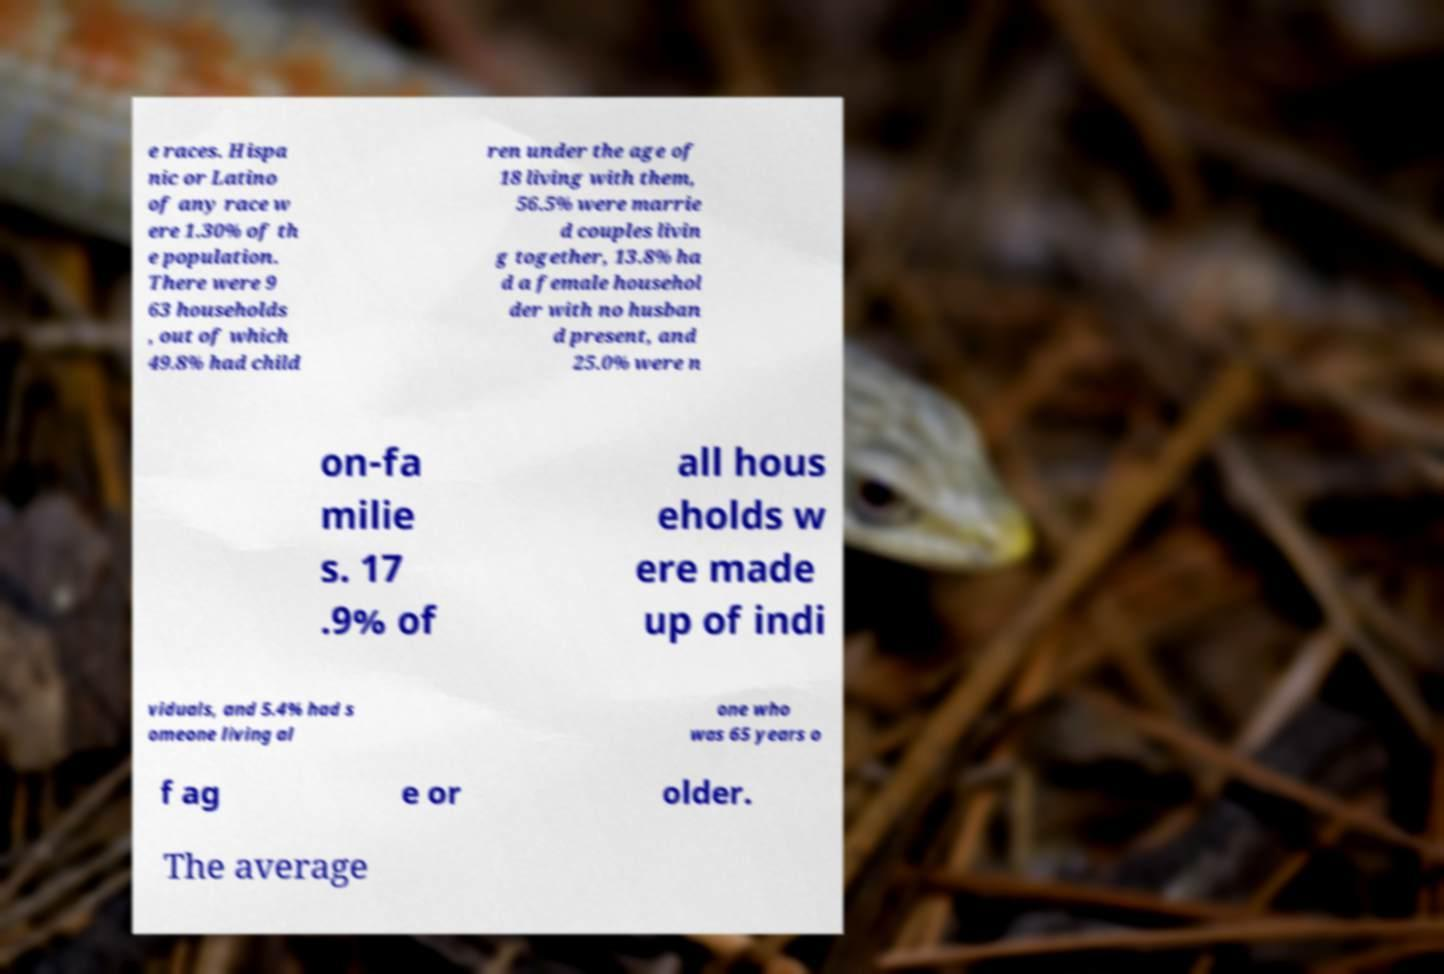Please identify and transcribe the text found in this image. e races. Hispa nic or Latino of any race w ere 1.30% of th e population. There were 9 63 households , out of which 49.8% had child ren under the age of 18 living with them, 56.5% were marrie d couples livin g together, 13.8% ha d a female househol der with no husban d present, and 25.0% were n on-fa milie s. 17 .9% of all hous eholds w ere made up of indi viduals, and 5.4% had s omeone living al one who was 65 years o f ag e or older. The average 